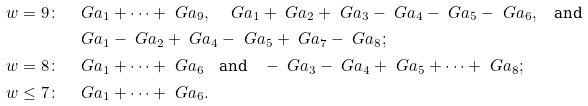Convert formula to latex. <formula><loc_0><loc_0><loc_500><loc_500>w = 9 \colon & \quad \ G a _ { 1 } + \dots + \ G a _ { 9 } , \quad \ G a _ { 1 } + \ G a _ { 2 } + \ G a _ { 3 } - \ G a _ { 4 } - \ G a _ { 5 } - \ G a _ { 6 } , \quad \text {and} \\ & \quad \ G a _ { 1 } - \ G a _ { 2 } + \ G a _ { 4 } - \ G a _ { 5 } + \ G a _ { 7 } - \ G a _ { 8 } ; \\ w = 8 \colon & \quad \ G a _ { 1 } + \dots + \ G a _ { 6 } \quad \text {and} \quad - \ G a _ { 3 } - \ G a _ { 4 } + \ G a _ { 5 } + \dots + \ G a _ { 8 } ; \\ w \leq 7 \colon & \quad \ G a _ { 1 } + \dots + \ G a _ { 6 } . \\</formula> 